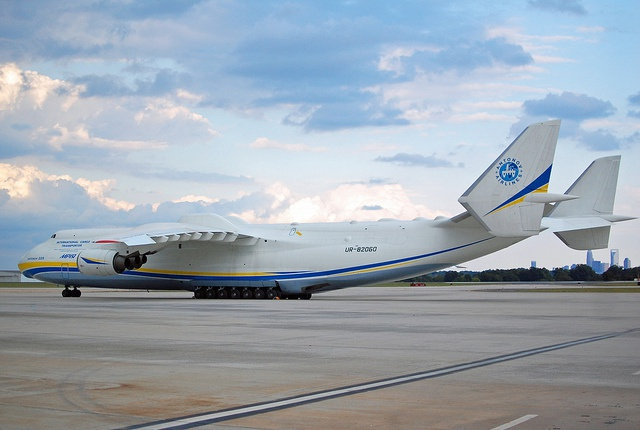Describe the objects in this image and their specific colors. I can see a airplane in gray, darkgray, lightgray, and black tones in this image. 